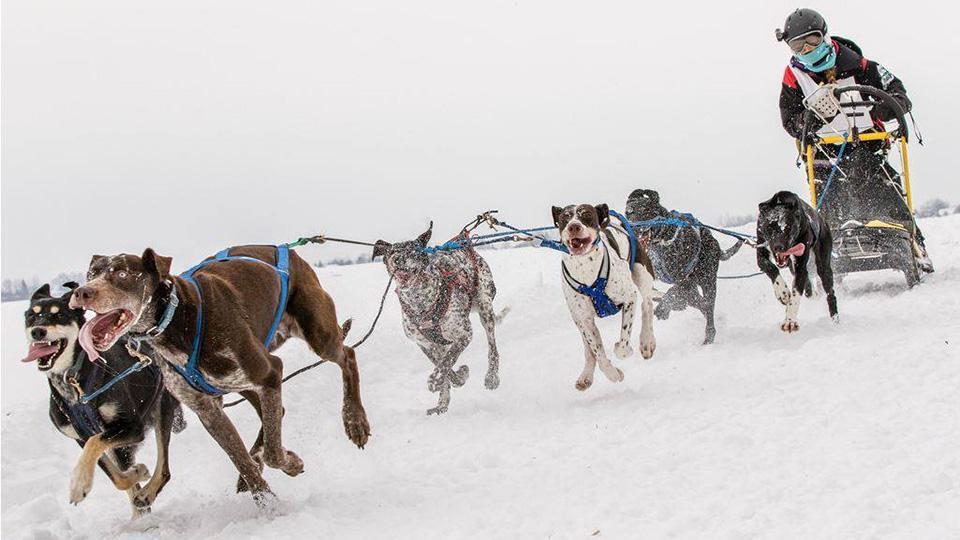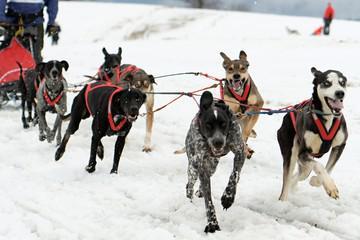The first image is the image on the left, the second image is the image on the right. For the images displayed, is the sentence "The leading dogs are blonde/gold, and black with a lighter muzzle." factually correct? Answer yes or no. No. The first image is the image on the left, the second image is the image on the right. Analyze the images presented: Is the assertion "The dog teams in the two images are each forward-facing, but headed in different directions." valid? Answer yes or no. Yes. 